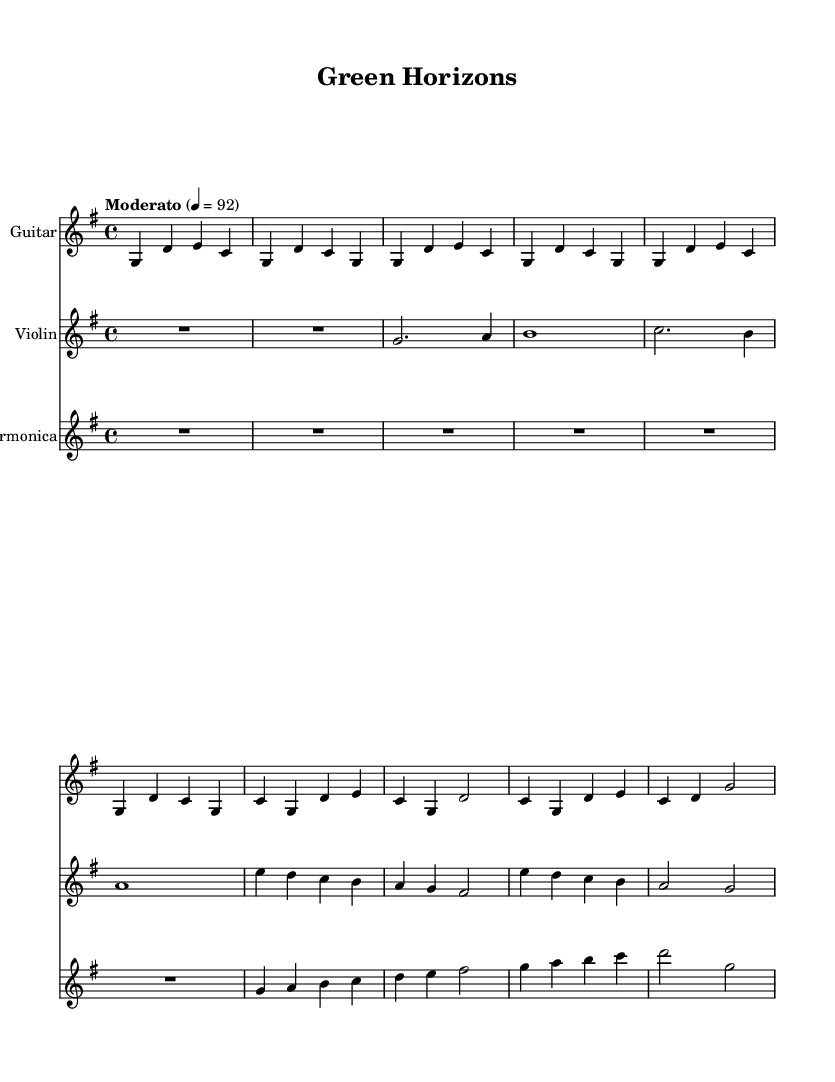What is the key signature of this music? The key signature is G major, which has one sharp (F#). This is determined by the instruction `\key g \major` at the beginning of the score.
Answer: G major What is the time signature of the piece? The time signature is 4/4, indicating four beats per measure. This can be found in the score marker `\time 4/4`.
Answer: 4/4 What is the tempo marking for this piece? The tempo marking is Moderato, set at a quarter note equaling 92 beats per minute. This is indicated by the instruction `\tempo "Moderato" 4 = 92`.
Answer: Moderato How many measures are in the chorus section? The chorus section consists of four measures. Counting the measures from the score, we can see that there are four distinct groupings of notes.
Answer: 4 Which instruments are featured in the score? The featured instruments are Guitar, Violin, and Harmonica. This is indicated by the staff headers in the score, each specifying an instrument.
Answer: Guitar, Violin, Harmonica What is the thematic message conveyed in the lyrics? The thematic message highlights sustainable living and the collective effort towards nurturing the environment. This is derived from keywords and phrases such as "sustainable dreams" and "together we'll nurture this beautiful land" in the lyrics presented.
Answer: Sustainable living 